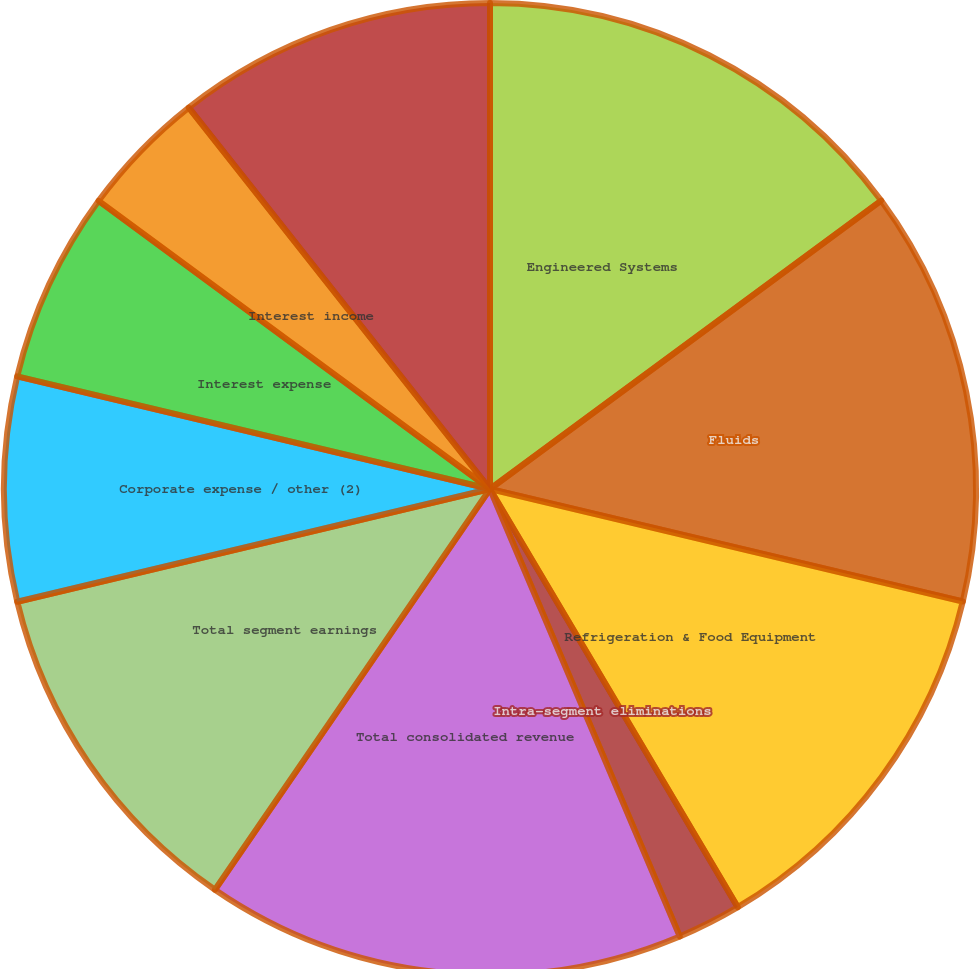<chart> <loc_0><loc_0><loc_500><loc_500><pie_chart><fcel>Engineered Systems<fcel>Fluids<fcel>Refrigeration & Food Equipment<fcel>Intra-segment eliminations<fcel>Total consolidated revenue<fcel>Total segment earnings<fcel>Corporate expense / other (2)<fcel>Interest expense<fcel>Interest income<fcel>Earnings before provision for<nl><fcel>14.89%<fcel>13.83%<fcel>12.77%<fcel>2.13%<fcel>15.96%<fcel>11.7%<fcel>7.45%<fcel>6.38%<fcel>4.26%<fcel>10.64%<nl></chart> 